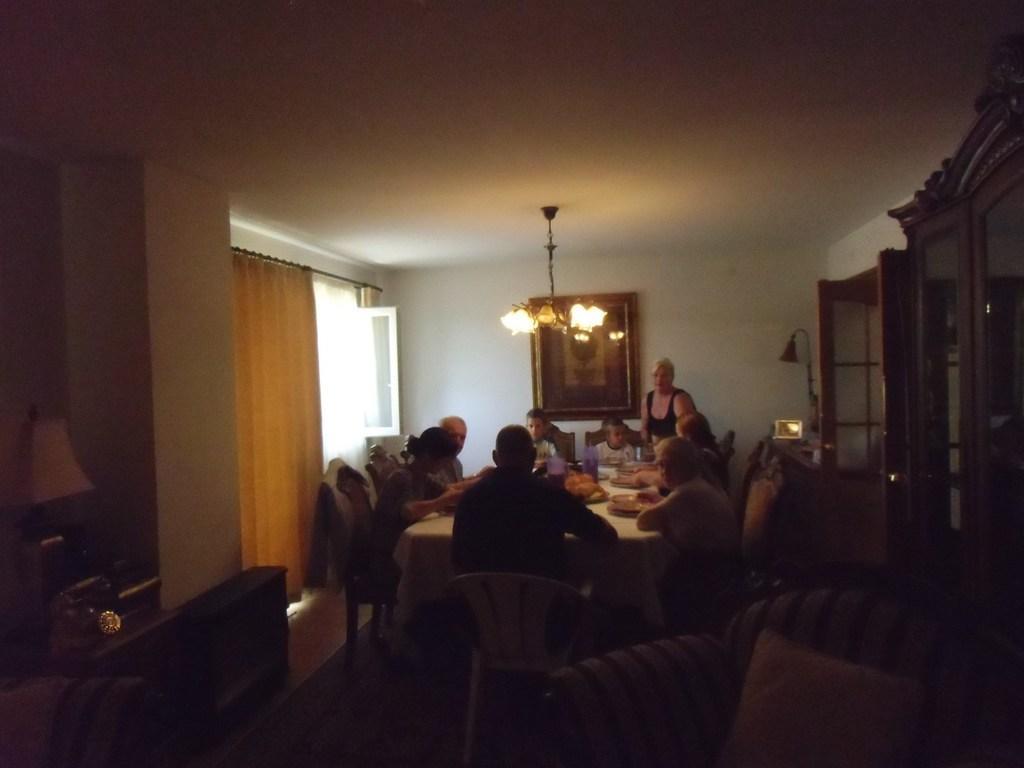In one or two sentences, can you explain what this image depicts? In this image we have a group of people who are sitting on the chair and having food. On the table we have few objects on the above we have a chandelier and on the left side of the image we have a curtain and a window. Behind this people we have a white color wall. 